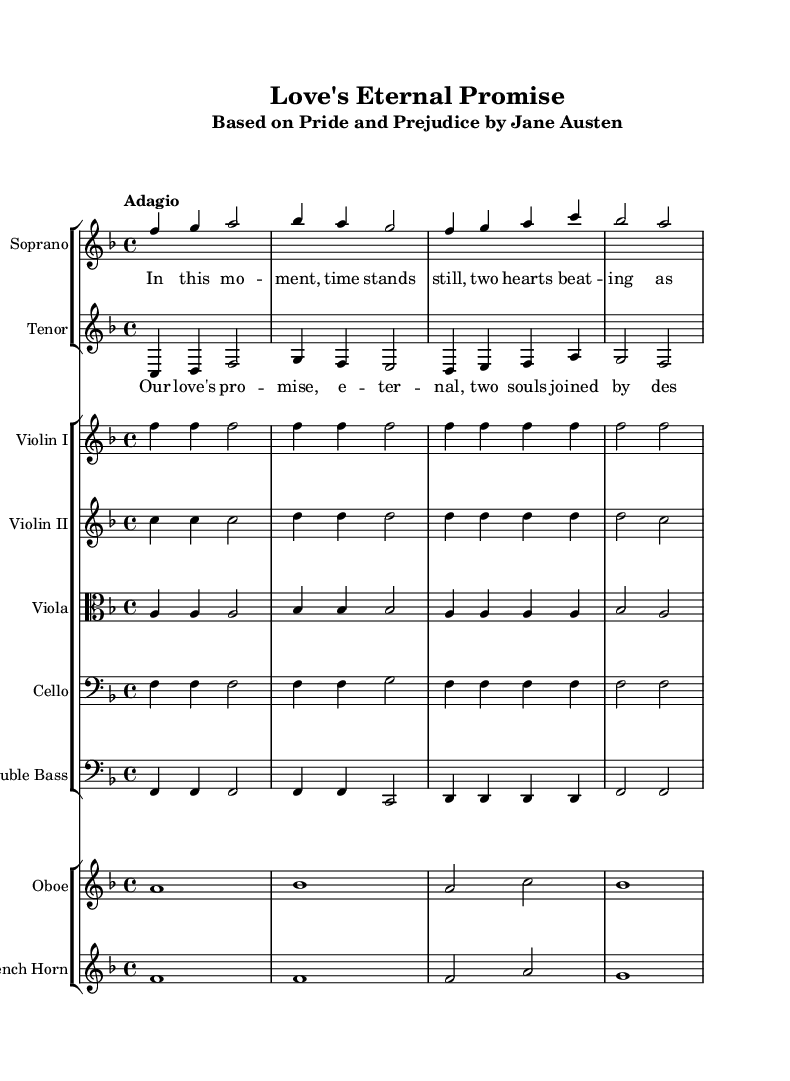What is the key signature of this music? The key signature is F major, indicated by one flat (B flat), which is found on the staff at the beginning of the score.
Answer: F major What is the time signature of this music? The time signature is 4/4, which is displayed at the beginning of the score, indicating four beats per measure.
Answer: 4/4 What tempo marking is given in the score? The tempo marking is "Adagio," which suggests a slow and leisurely pace for the performance.
Answer: Adagio How many measures are in the excerpt provided? Counting the measures in the score, there are a total of 8 measures present in the excerpt.
Answer: 8 What instrument plays the melody alongside the soprano? The tenor plays the melody alongside the soprano, as indicated in the score with a separate staff for the tenor voice.
Answer: Tenor How does the soprano's lyrics relate to the theme of the opera? The soprano's lyrics, "In this moment, time stands still, two hearts beating as one," emphasize a romantic and intimate moment, resonating with the opera's theme based on "Pride and Prejudice."
Answer: Romantic intimacy What is the overall mood conveyed by the musical dynamics indicated in the score? The mood is likely tender and contemplative, as the dynamics are primarily soft with no significant crescendos or abrupt changes, reinforcing the romantic theme.
Answer: Tender and contemplative 